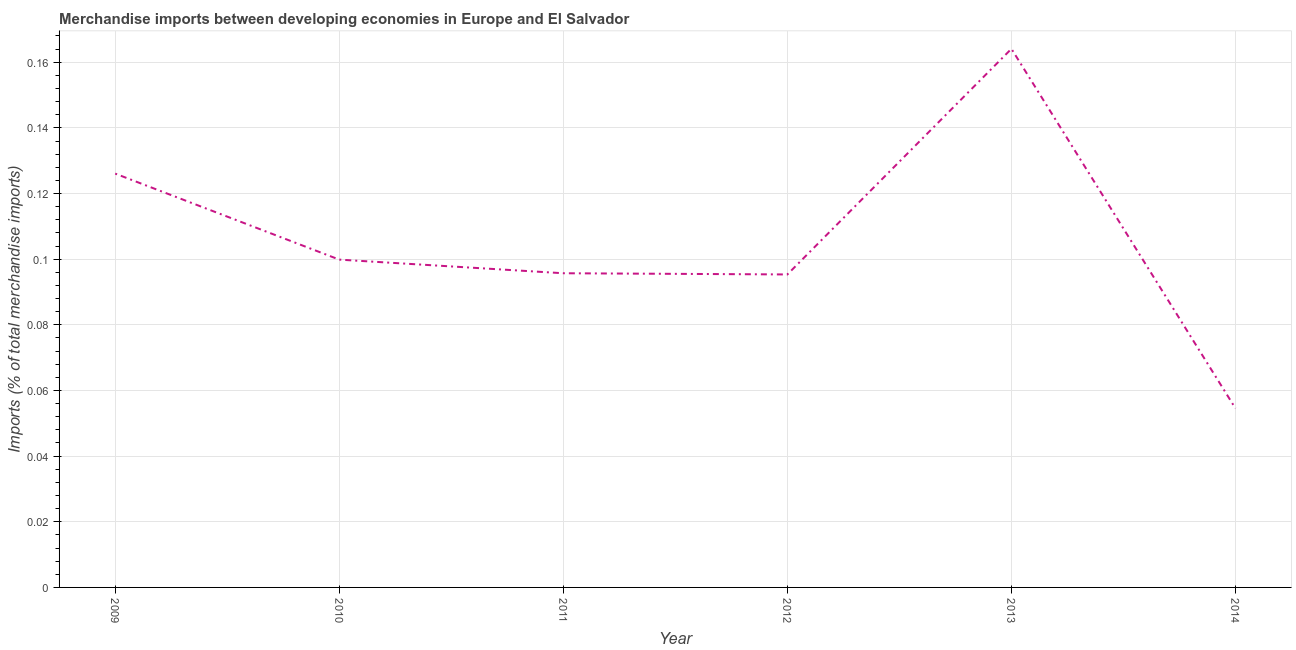What is the merchandise imports in 2009?
Offer a very short reply. 0.13. Across all years, what is the maximum merchandise imports?
Provide a short and direct response. 0.16. Across all years, what is the minimum merchandise imports?
Your answer should be compact. 0.05. In which year was the merchandise imports maximum?
Provide a succinct answer. 2013. In which year was the merchandise imports minimum?
Your answer should be compact. 2014. What is the sum of the merchandise imports?
Give a very brief answer. 0.64. What is the difference between the merchandise imports in 2009 and 2014?
Provide a short and direct response. 0.07. What is the average merchandise imports per year?
Your answer should be compact. 0.11. What is the median merchandise imports?
Give a very brief answer. 0.1. What is the ratio of the merchandise imports in 2010 to that in 2011?
Give a very brief answer. 1.04. What is the difference between the highest and the second highest merchandise imports?
Give a very brief answer. 0.04. Is the sum of the merchandise imports in 2011 and 2013 greater than the maximum merchandise imports across all years?
Your answer should be compact. Yes. What is the difference between the highest and the lowest merchandise imports?
Keep it short and to the point. 0.11. In how many years, is the merchandise imports greater than the average merchandise imports taken over all years?
Make the answer very short. 2. How many lines are there?
Make the answer very short. 1. How many years are there in the graph?
Provide a short and direct response. 6. What is the difference between two consecutive major ticks on the Y-axis?
Provide a short and direct response. 0.02. Does the graph contain any zero values?
Your response must be concise. No. What is the title of the graph?
Make the answer very short. Merchandise imports between developing economies in Europe and El Salvador. What is the label or title of the Y-axis?
Make the answer very short. Imports (% of total merchandise imports). What is the Imports (% of total merchandise imports) of 2009?
Provide a succinct answer. 0.13. What is the Imports (% of total merchandise imports) of 2010?
Make the answer very short. 0.1. What is the Imports (% of total merchandise imports) in 2011?
Provide a short and direct response. 0.1. What is the Imports (% of total merchandise imports) of 2012?
Provide a succinct answer. 0.1. What is the Imports (% of total merchandise imports) of 2013?
Your answer should be very brief. 0.16. What is the Imports (% of total merchandise imports) of 2014?
Provide a short and direct response. 0.05. What is the difference between the Imports (% of total merchandise imports) in 2009 and 2010?
Offer a terse response. 0.03. What is the difference between the Imports (% of total merchandise imports) in 2009 and 2011?
Give a very brief answer. 0.03. What is the difference between the Imports (% of total merchandise imports) in 2009 and 2012?
Make the answer very short. 0.03. What is the difference between the Imports (% of total merchandise imports) in 2009 and 2013?
Offer a terse response. -0.04. What is the difference between the Imports (% of total merchandise imports) in 2009 and 2014?
Make the answer very short. 0.07. What is the difference between the Imports (% of total merchandise imports) in 2010 and 2011?
Make the answer very short. 0. What is the difference between the Imports (% of total merchandise imports) in 2010 and 2012?
Your answer should be compact. 0. What is the difference between the Imports (% of total merchandise imports) in 2010 and 2013?
Offer a terse response. -0.06. What is the difference between the Imports (% of total merchandise imports) in 2010 and 2014?
Keep it short and to the point. 0.05. What is the difference between the Imports (% of total merchandise imports) in 2011 and 2012?
Offer a terse response. 0. What is the difference between the Imports (% of total merchandise imports) in 2011 and 2013?
Make the answer very short. -0.07. What is the difference between the Imports (% of total merchandise imports) in 2011 and 2014?
Make the answer very short. 0.04. What is the difference between the Imports (% of total merchandise imports) in 2012 and 2013?
Your response must be concise. -0.07. What is the difference between the Imports (% of total merchandise imports) in 2012 and 2014?
Provide a succinct answer. 0.04. What is the difference between the Imports (% of total merchandise imports) in 2013 and 2014?
Keep it short and to the point. 0.11. What is the ratio of the Imports (% of total merchandise imports) in 2009 to that in 2010?
Offer a terse response. 1.26. What is the ratio of the Imports (% of total merchandise imports) in 2009 to that in 2011?
Your response must be concise. 1.32. What is the ratio of the Imports (% of total merchandise imports) in 2009 to that in 2012?
Your response must be concise. 1.32. What is the ratio of the Imports (% of total merchandise imports) in 2009 to that in 2013?
Your response must be concise. 0.77. What is the ratio of the Imports (% of total merchandise imports) in 2009 to that in 2014?
Give a very brief answer. 2.31. What is the ratio of the Imports (% of total merchandise imports) in 2010 to that in 2011?
Ensure brevity in your answer.  1.04. What is the ratio of the Imports (% of total merchandise imports) in 2010 to that in 2012?
Your answer should be very brief. 1.05. What is the ratio of the Imports (% of total merchandise imports) in 2010 to that in 2013?
Provide a short and direct response. 0.61. What is the ratio of the Imports (% of total merchandise imports) in 2010 to that in 2014?
Provide a short and direct response. 1.83. What is the ratio of the Imports (% of total merchandise imports) in 2011 to that in 2012?
Your answer should be very brief. 1. What is the ratio of the Imports (% of total merchandise imports) in 2011 to that in 2013?
Ensure brevity in your answer.  0.58. What is the ratio of the Imports (% of total merchandise imports) in 2011 to that in 2014?
Your answer should be very brief. 1.75. What is the ratio of the Imports (% of total merchandise imports) in 2012 to that in 2013?
Offer a terse response. 0.58. What is the ratio of the Imports (% of total merchandise imports) in 2012 to that in 2014?
Keep it short and to the point. 1.75. What is the ratio of the Imports (% of total merchandise imports) in 2013 to that in 2014?
Your response must be concise. 3.01. 